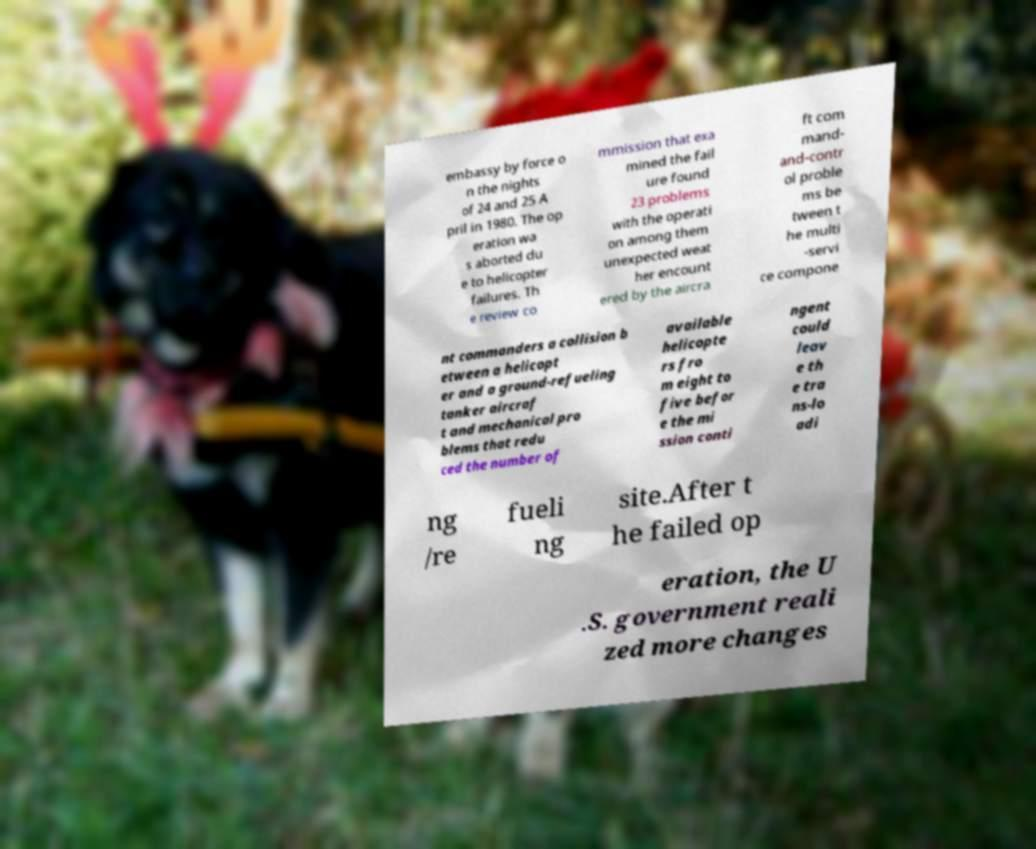What messages or text are displayed in this image? I need them in a readable, typed format. embassy by force o n the nights of 24 and 25 A pril in 1980. The op eration wa s aborted du e to helicopter failures. Th e review co mmission that exa mined the fail ure found 23 problems with the operati on among them unexpected weat her encount ered by the aircra ft com mand- and-contr ol proble ms be tween t he multi -servi ce compone nt commanders a collision b etween a helicopt er and a ground-refueling tanker aircraf t and mechanical pro blems that redu ced the number of available helicopte rs fro m eight to five befor e the mi ssion conti ngent could leav e th e tra ns-lo adi ng /re fueli ng site.After t he failed op eration, the U .S. government reali zed more changes 